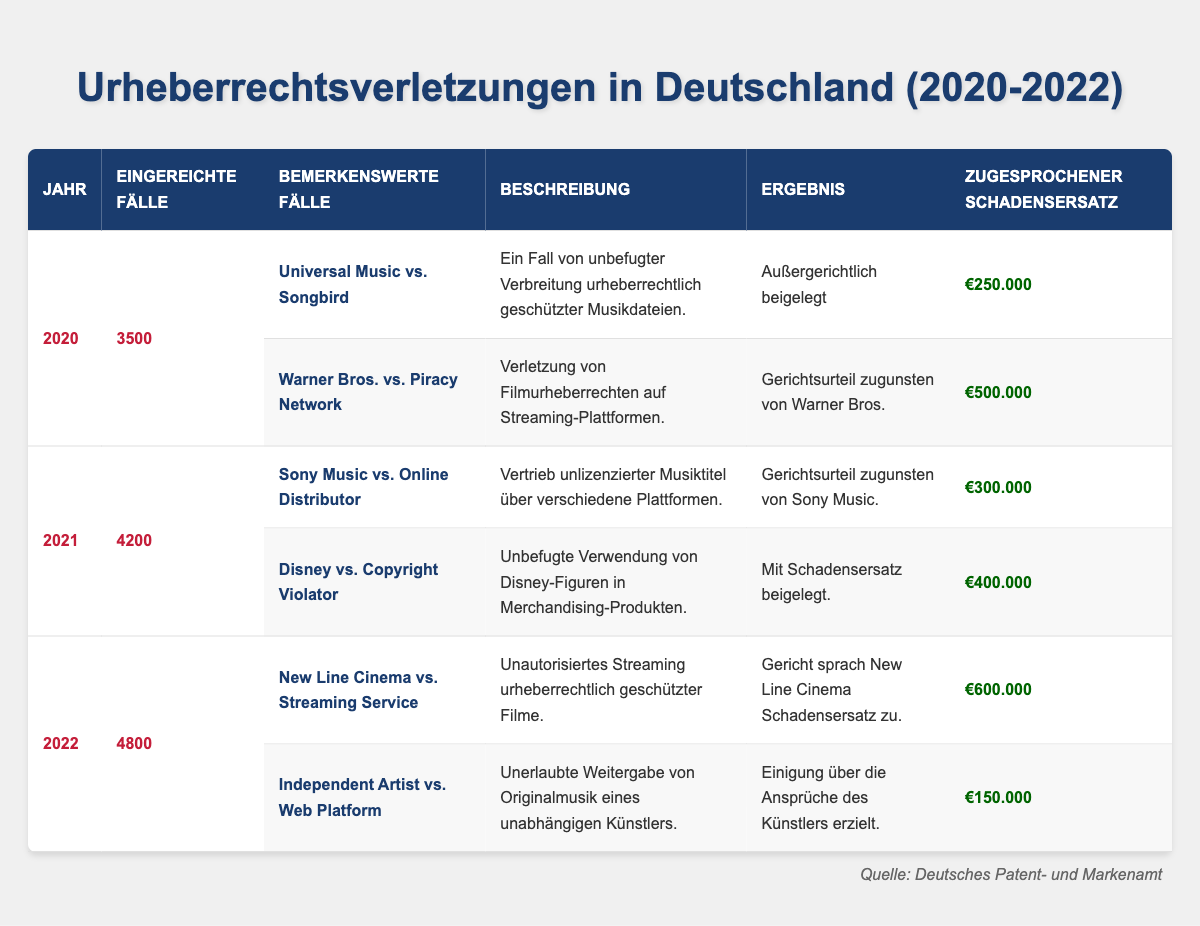What was the total number of copyright infringement cases filed in Germany from 2020 to 2022? The table shows the number of cases filed for each year: 2020 (3500), 2021 (4200), and 2022 (4800). Adding these gives: 3500 + 4200 + 4800 = 12500.
Answer: 12500 Which year had the highest number of cases filed? By examining the cases filed for each year, I see 2020 had 3500, 2021 had 4200, and 2022 had 4800. The highest number is 4800 in 2022.
Answer: 2022 What is the outcome of the case "Warner Bros. vs. Piracy Network"? The table states that the outcome of this case is "Court ruling in favor of Warner Bros.".
Answer: Court ruling in favor of Warner Bros How much in damages was awarded in the case "New Line Cinema vs. Streaming Service"? The table specifies that damages awarded in this case were €600,000.
Answer: €600,000 What is the difference in the number of cases filed between 2021 and 2022? The table shows cases filed: 2021 had 4200 and 2022 had 4800. The difference is 4800 - 4200 = 600.
Answer: 600 In which year did the "Disney vs. Copyright Violator" case occur and what was the damages awarded? The table indicates that this case occurred in 2021 and the damages awarded were €400,000.
Answer: 2021, €400,000 What was the average damages awarded in 2020? The notable cases for 2020 are "Universal Music vs. Songbird" (€250,000) and "Warner Bros. vs. Piracy Network" (€500,000). The total damages are €250,000 + €500,000 = €750,000 and there are 2 cases, so the average is €750,000 / 2 = €375,000.
Answer: €375,000 Did the number of cases filed increase every year from 2020 to 2022? Yes, the numbers of cases filed were 3500 in 2020, 4200 in 2021, and 4800 in 2022, showing a consistent increase year on year.
Answer: Yes Which case had the highest damages awarded and in which year? The case "New Line Cinema vs. Streaming Service" had the highest damages awarded of €600,000 in 2022.
Answer: "New Line Cinema vs. Streaming Service", 2022 What was the total damages awarded across all notable cases in 2021? The damages awarded in 2021 are €300,000 (Sony Music) + €400,000 (Disney) = €700,000.
Answer: €700,000 